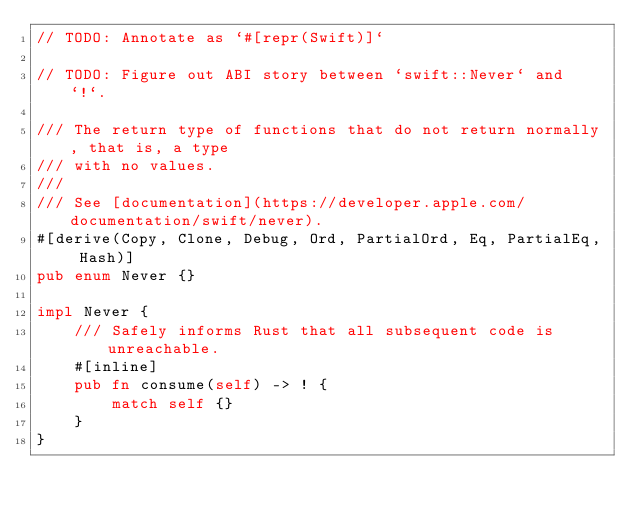Convert code to text. <code><loc_0><loc_0><loc_500><loc_500><_Rust_>// TODO: Annotate as `#[repr(Swift)]`

// TODO: Figure out ABI story between `swift::Never` and `!`.

/// The return type of functions that do not return normally, that is, a type
/// with no values.
///
/// See [documentation](https://developer.apple.com/documentation/swift/never).
#[derive(Copy, Clone, Debug, Ord, PartialOrd, Eq, PartialEq, Hash)]
pub enum Never {}

impl Never {
    /// Safely informs Rust that all subsequent code is unreachable.
    #[inline]
    pub fn consume(self) -> ! {
        match self {}
    }
}
</code> 